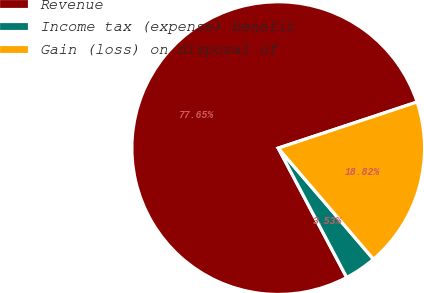Convert chart to OTSL. <chart><loc_0><loc_0><loc_500><loc_500><pie_chart><fcel>Revenue<fcel>Income tax (expense) benefit<fcel>Gain (loss) on disposal of<nl><fcel>77.65%<fcel>3.53%<fcel>18.82%<nl></chart> 